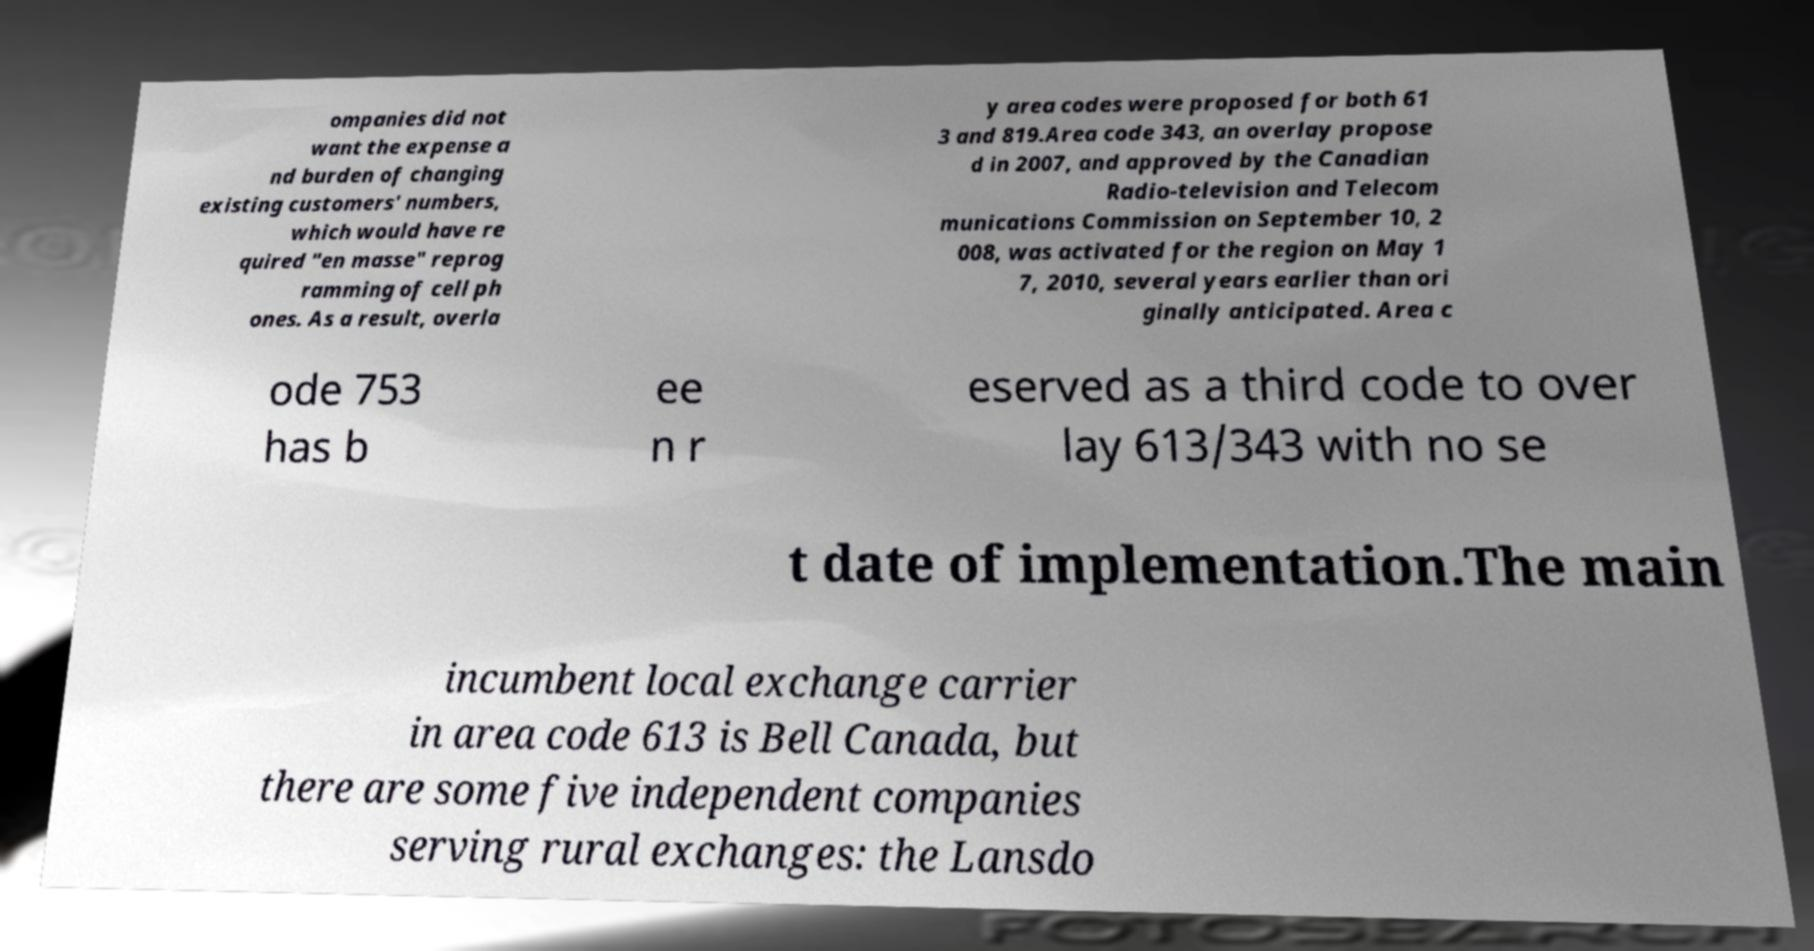Please identify and transcribe the text found in this image. ompanies did not want the expense a nd burden of changing existing customers' numbers, which would have re quired "en masse" reprog ramming of cell ph ones. As a result, overla y area codes were proposed for both 61 3 and 819.Area code 343, an overlay propose d in 2007, and approved by the Canadian Radio-television and Telecom munications Commission on September 10, 2 008, was activated for the region on May 1 7, 2010, several years earlier than ori ginally anticipated. Area c ode 753 has b ee n r eserved as a third code to over lay 613/343 with no se t date of implementation.The main incumbent local exchange carrier in area code 613 is Bell Canada, but there are some five independent companies serving rural exchanges: the Lansdo 